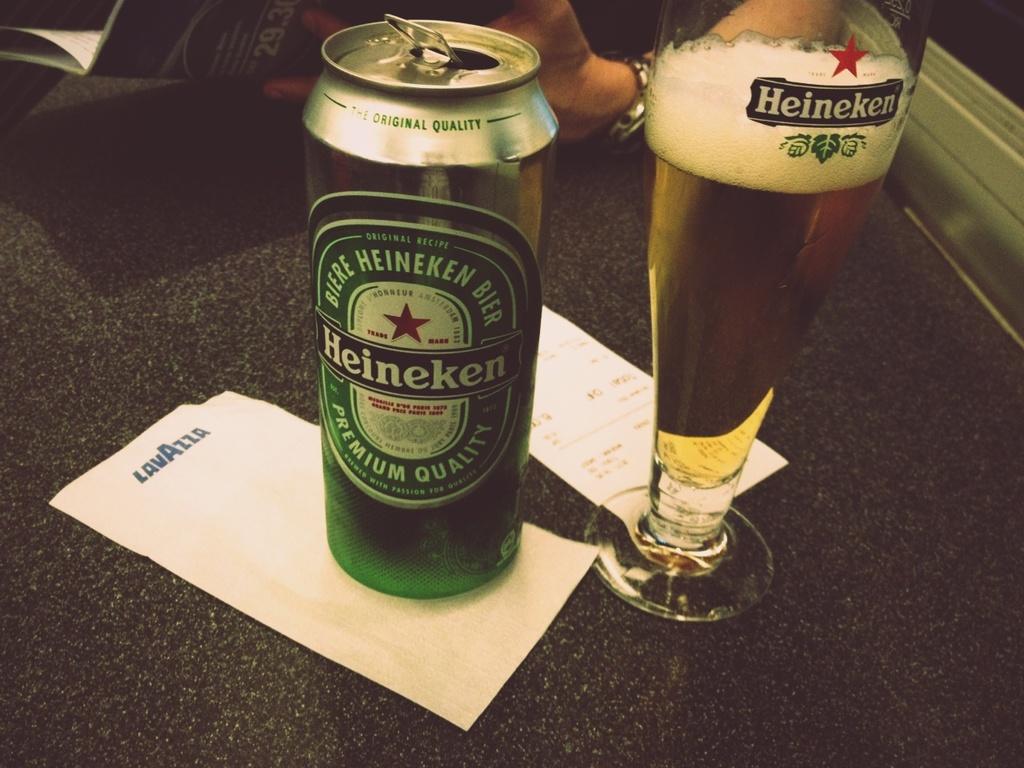What brand of beer is in the can?
Make the answer very short. Heineken. Is heineken a premium quality beer?
Ensure brevity in your answer.  Yes. 